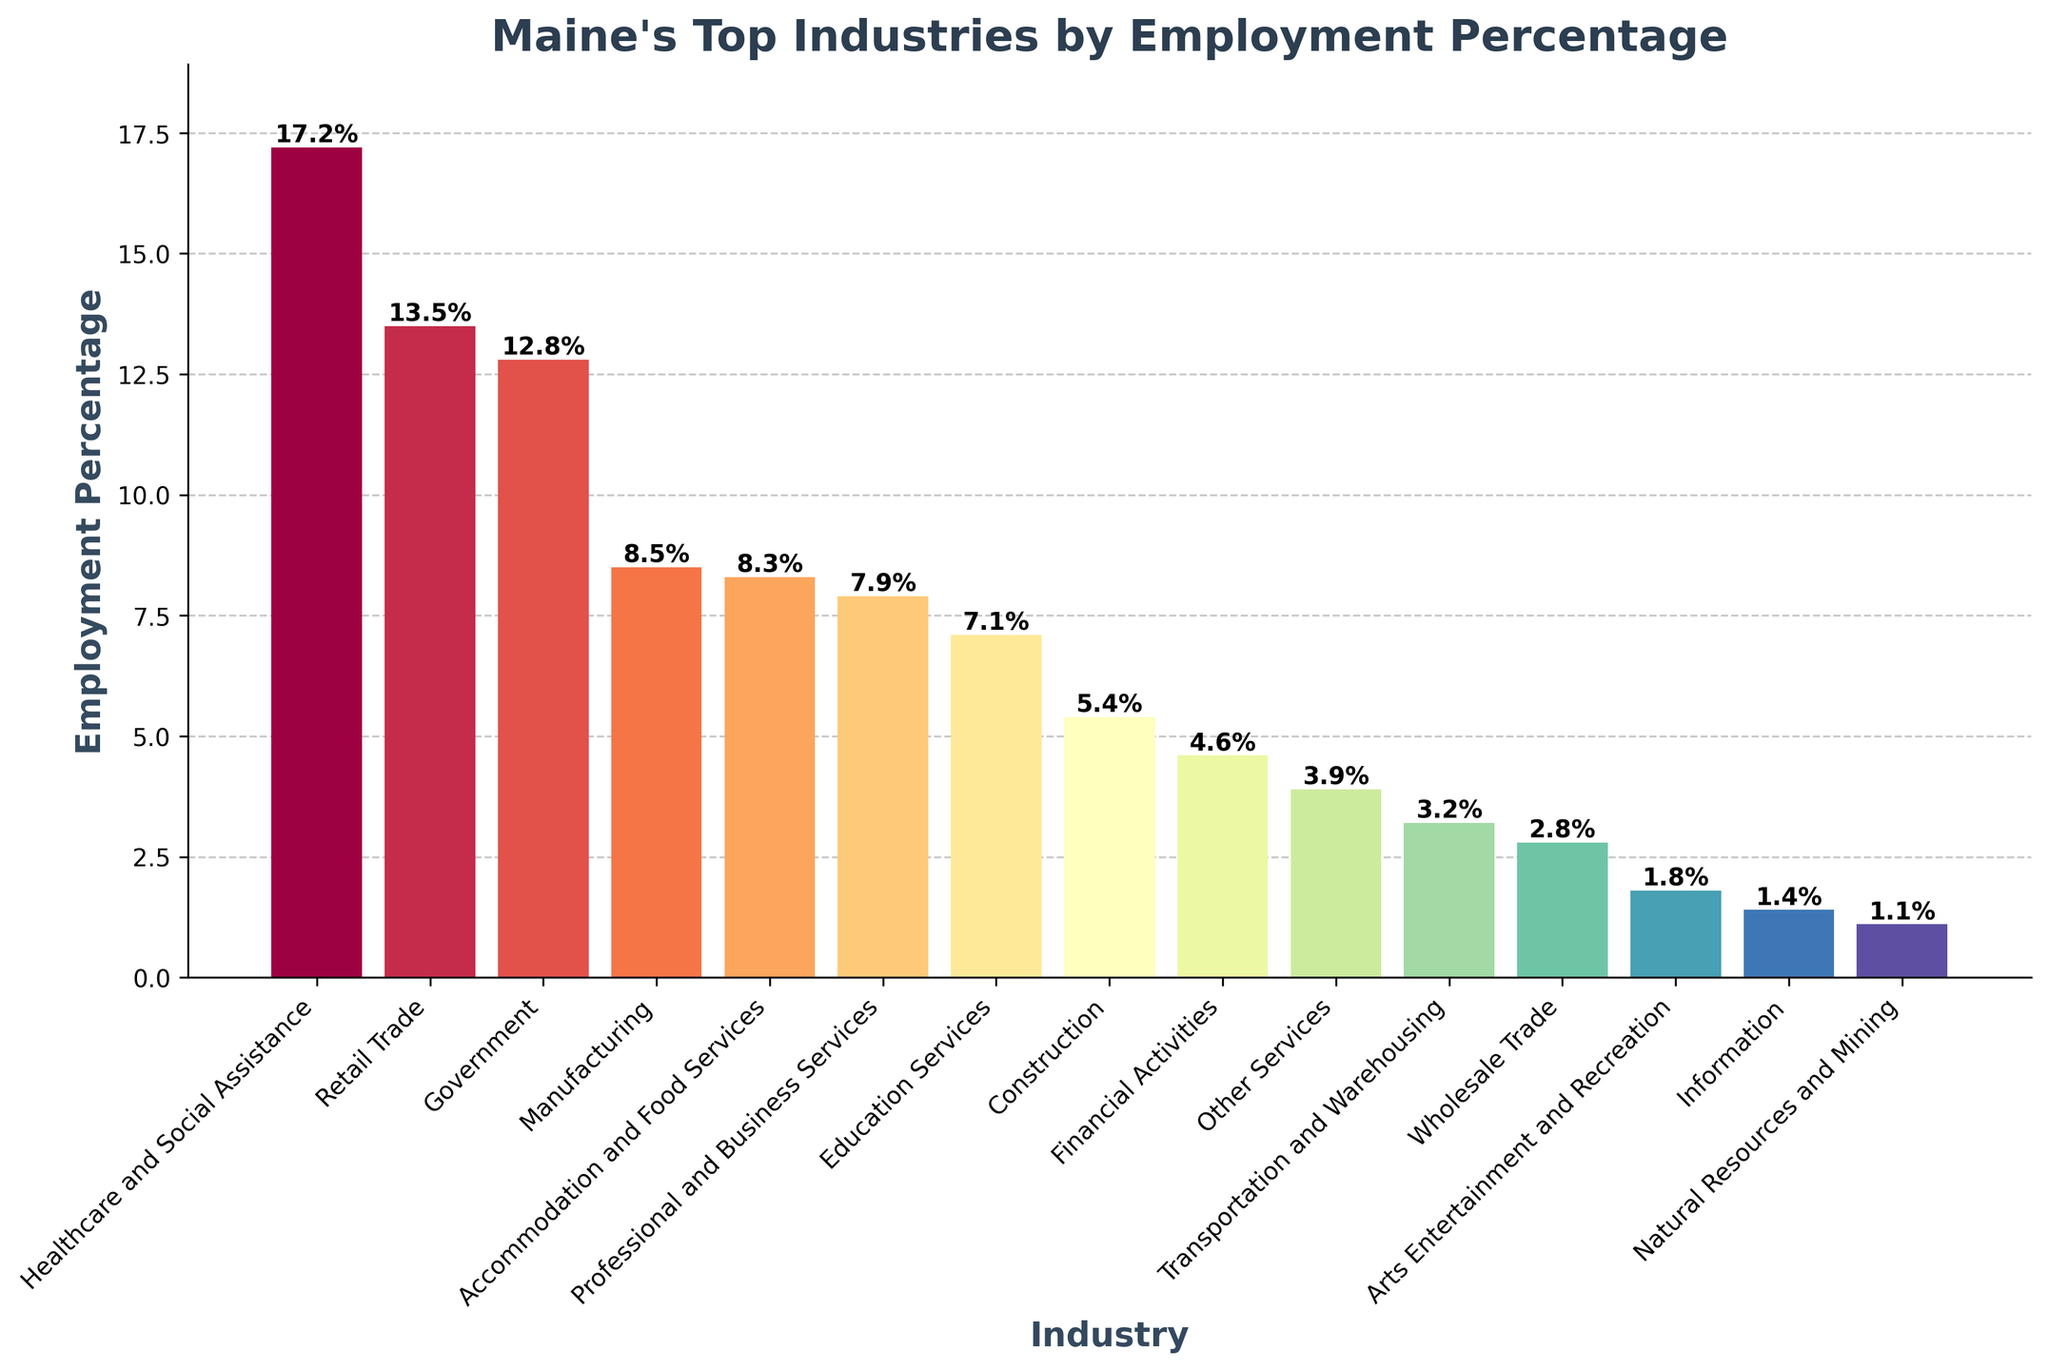Which industry has the highest employment percentage in Maine? By looking at the height of the bars, the tallest bar corresponds to the Healthcare and Social Assistance industry.
Answer: Healthcare and Social Assistance What is the combined employment percentage for the top three industries? The percentages for the top three industries are Healthcare and Social Assistance (17.2%), Retail Trade (13.5%), and Government (12.8%). Summing these gives 17.2 + 13.5 + 12.8 = 43.5%.
Answer: 43.5% How does the employment percentage of Manufacturing compare to Education Services? The heights for Manufacturing and Education Services are 8.5% and 7.1% respectively. Manufacturing has a higher employment percentage.
Answer: Manufacturing Which industry is represented by the fourth tallest bar? The fourth tallest bar corresponds to the Manufacturing industry.
Answer: Manufacturing What is the difference in employment percentage between the highest and lowest industry? The highest employment percentage is Healthcare and Social Assistance (17.2%) and the lowest is Natural Resources and Mining (1.1%). The difference is 17.2 - 1.1 = 16.1%.
Answer: 16.1% Are there any industries with an employment percentage less than 5%? If yes, name them. By checking the bars with heights less than 5%, the industries are Financial Activities (4.6%), Other Services (3.9%), Transportation and Warehousing (3.2%), Wholesale Trade (2.8%), Arts Entertainment and Recreation (1.8%), Information (1.4%), and Natural Resources and Mining (1.1%).
Answer: Yes, Financial Activities, Other Services, Transportation and Warehousing, Wholesale Trade, Arts Entertainment and Recreation, Information, Natural Resources and Mining Which industry has a larger employment percentage: Construction or Financial Activities? Construction has an employment percentage of 5.4% and Financial Activities has 4.6%. Construction has a larger percentage.
Answer: Construction What is the average employment percentage of the three least represented industries? The three least represented industries are Information (1.4%), Natural Resources and Mining (1.1%), and Arts Entertainment and Recreation (1.8%). The average is (1.4 + 1.1 + 1.8) / 3 = 1.43%.
Answer: 1.43% If you combine the employment percentages of Professional and Business Services, and Accommodation and Food Services, does it exceed the percentage of Retail Trade? Professional and Business Services has 7.9% and Accommodation and Food Services has 8.3%. Combined, they are 7.9 + 8.3 = 16.2%, which is greater than Retail Trade's 13.5%.
Answer: Yes Are there more industries with employment percentages above or below 5%? There are 8 industries above 5% (Healthcare and Social Assistance, Retail Trade, Government, Manufacturing, Accommodation and Food Services, Professional and Business Services, Education Services, Construction) and 7 industries below 5%. Therefore, there are more industries above 5%.
Answer: Above 